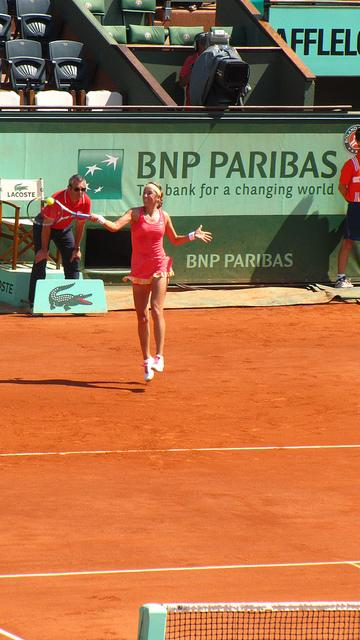What shirt brand is represented by the amphibious animal?

Choices:
A) polo
B) nike
C) lulu lemon
D) adidas polo 